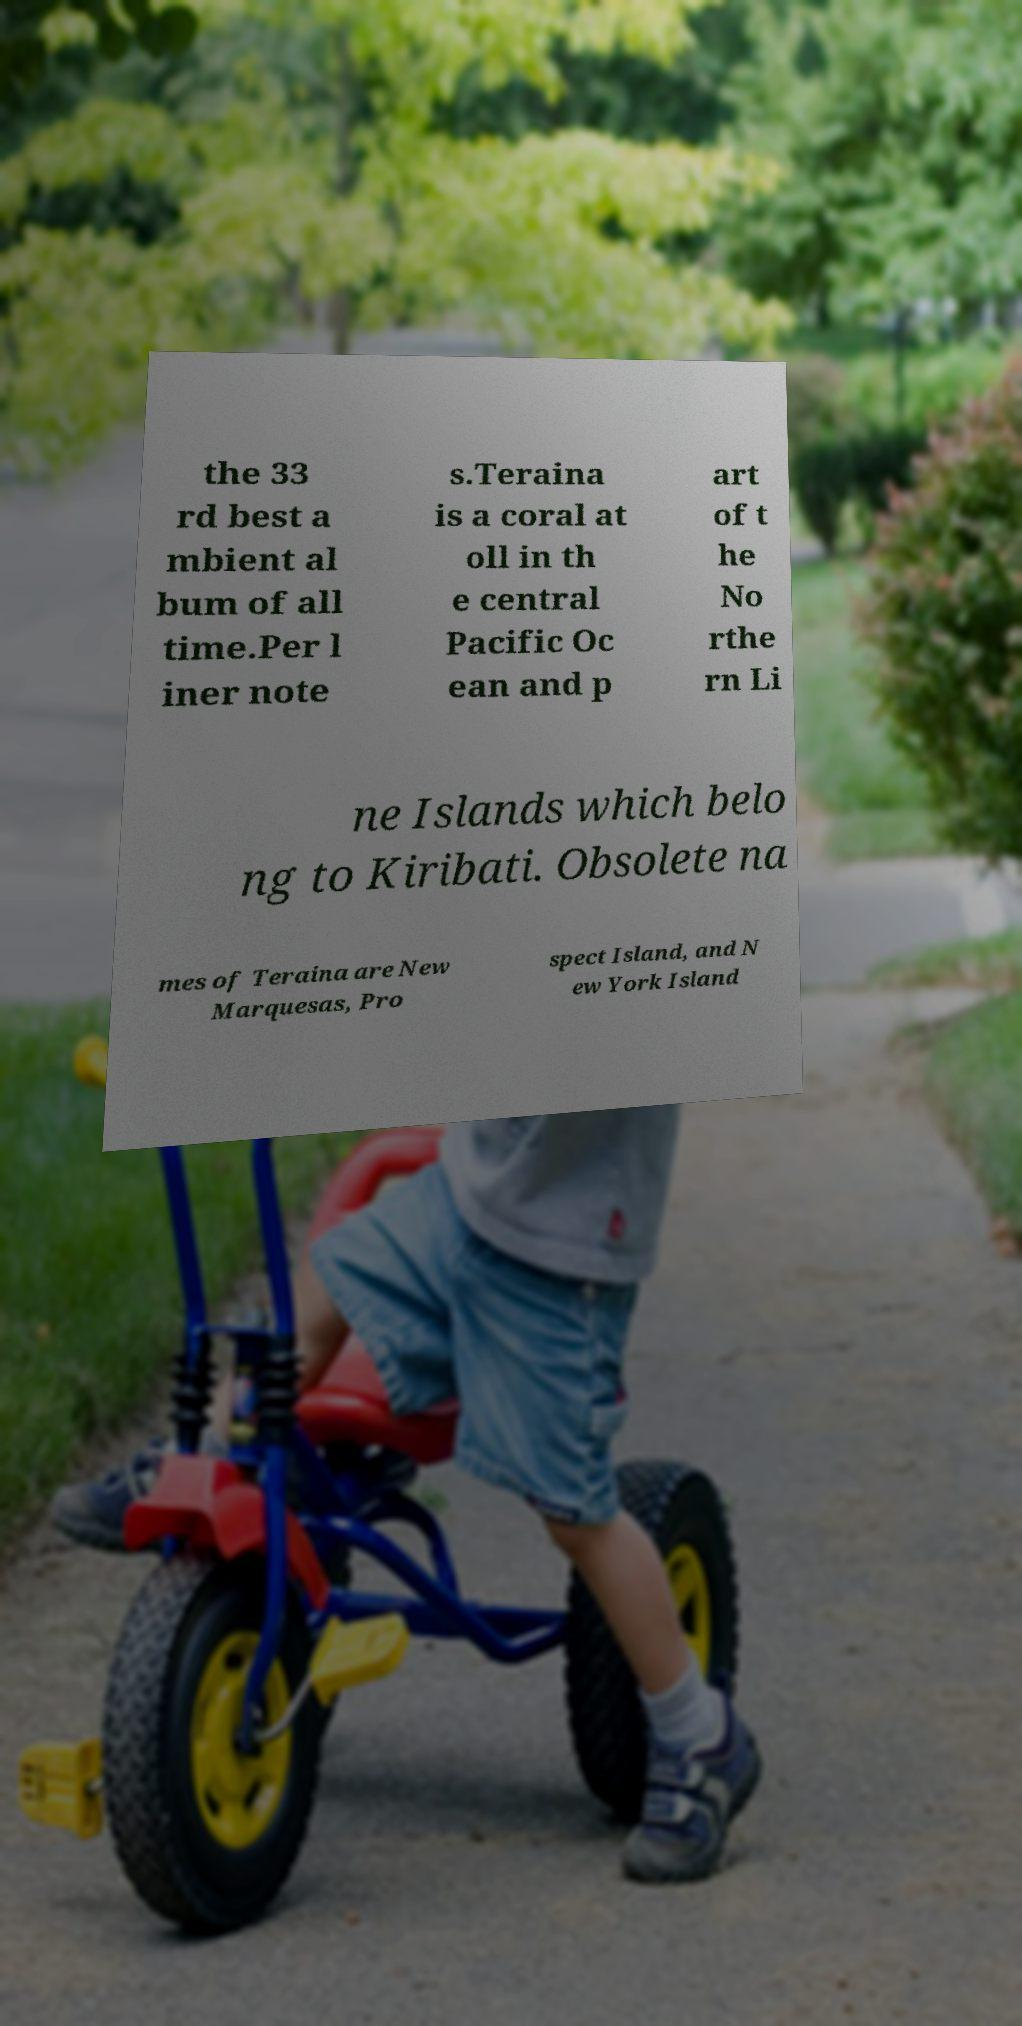Can you accurately transcribe the text from the provided image for me? the 33 rd best a mbient al bum of all time.Per l iner note s.Teraina is a coral at oll in th e central Pacific Oc ean and p art of t he No rthe rn Li ne Islands which belo ng to Kiribati. Obsolete na mes of Teraina are New Marquesas, Pro spect Island, and N ew York Island 